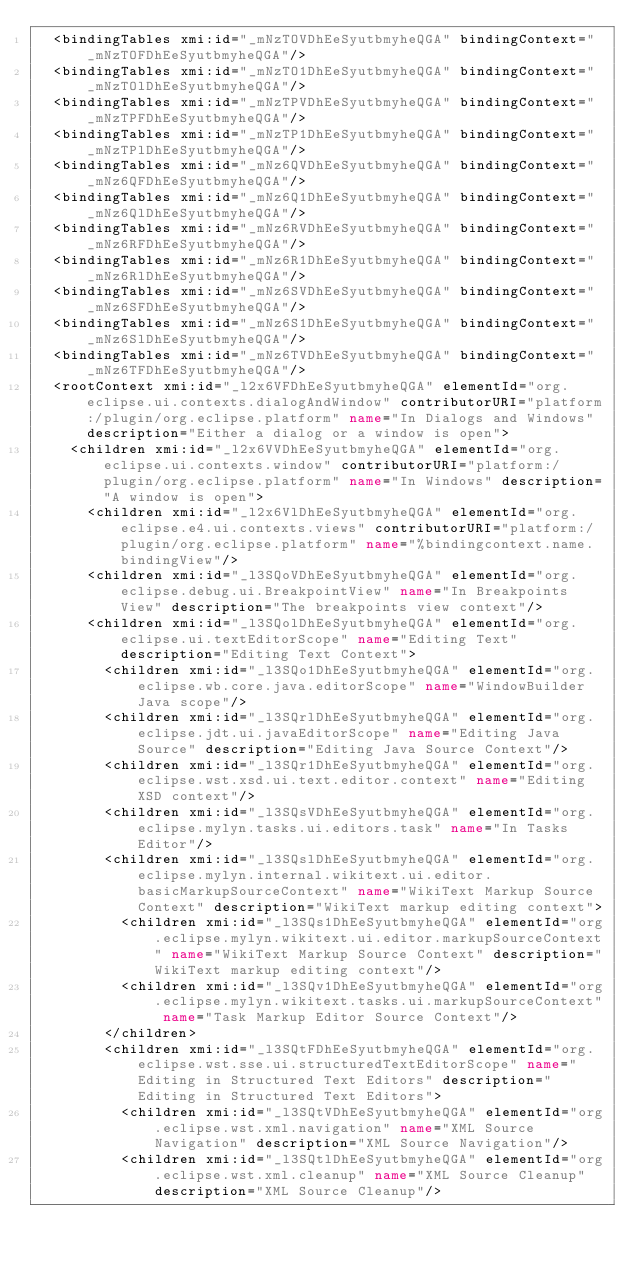Convert code to text. <code><loc_0><loc_0><loc_500><loc_500><_XML_>  <bindingTables xmi:id="_mNzTOVDhEeSyutbmyheQGA" bindingContext="_mNzTOFDhEeSyutbmyheQGA"/>
  <bindingTables xmi:id="_mNzTO1DhEeSyutbmyheQGA" bindingContext="_mNzTOlDhEeSyutbmyheQGA"/>
  <bindingTables xmi:id="_mNzTPVDhEeSyutbmyheQGA" bindingContext="_mNzTPFDhEeSyutbmyheQGA"/>
  <bindingTables xmi:id="_mNzTP1DhEeSyutbmyheQGA" bindingContext="_mNzTPlDhEeSyutbmyheQGA"/>
  <bindingTables xmi:id="_mNz6QVDhEeSyutbmyheQGA" bindingContext="_mNz6QFDhEeSyutbmyheQGA"/>
  <bindingTables xmi:id="_mNz6Q1DhEeSyutbmyheQGA" bindingContext="_mNz6QlDhEeSyutbmyheQGA"/>
  <bindingTables xmi:id="_mNz6RVDhEeSyutbmyheQGA" bindingContext="_mNz6RFDhEeSyutbmyheQGA"/>
  <bindingTables xmi:id="_mNz6R1DhEeSyutbmyheQGA" bindingContext="_mNz6RlDhEeSyutbmyheQGA"/>
  <bindingTables xmi:id="_mNz6SVDhEeSyutbmyheQGA" bindingContext="_mNz6SFDhEeSyutbmyheQGA"/>
  <bindingTables xmi:id="_mNz6S1DhEeSyutbmyheQGA" bindingContext="_mNz6SlDhEeSyutbmyheQGA"/>
  <bindingTables xmi:id="_mNz6TVDhEeSyutbmyheQGA" bindingContext="_mNz6TFDhEeSyutbmyheQGA"/>
  <rootContext xmi:id="_l2x6VFDhEeSyutbmyheQGA" elementId="org.eclipse.ui.contexts.dialogAndWindow" contributorURI="platform:/plugin/org.eclipse.platform" name="In Dialogs and Windows" description="Either a dialog or a window is open">
    <children xmi:id="_l2x6VVDhEeSyutbmyheQGA" elementId="org.eclipse.ui.contexts.window" contributorURI="platform:/plugin/org.eclipse.platform" name="In Windows" description="A window is open">
      <children xmi:id="_l2x6VlDhEeSyutbmyheQGA" elementId="org.eclipse.e4.ui.contexts.views" contributorURI="platform:/plugin/org.eclipse.platform" name="%bindingcontext.name.bindingView"/>
      <children xmi:id="_l3SQoVDhEeSyutbmyheQGA" elementId="org.eclipse.debug.ui.BreakpointView" name="In Breakpoints View" description="The breakpoints view context"/>
      <children xmi:id="_l3SQolDhEeSyutbmyheQGA" elementId="org.eclipse.ui.textEditorScope" name="Editing Text" description="Editing Text Context">
        <children xmi:id="_l3SQo1DhEeSyutbmyheQGA" elementId="org.eclipse.wb.core.java.editorScope" name="WindowBuilder Java scope"/>
        <children xmi:id="_l3SQrlDhEeSyutbmyheQGA" elementId="org.eclipse.jdt.ui.javaEditorScope" name="Editing Java Source" description="Editing Java Source Context"/>
        <children xmi:id="_l3SQr1DhEeSyutbmyheQGA" elementId="org.eclipse.wst.xsd.ui.text.editor.context" name="Editing XSD context"/>
        <children xmi:id="_l3SQsVDhEeSyutbmyheQGA" elementId="org.eclipse.mylyn.tasks.ui.editors.task" name="In Tasks Editor"/>
        <children xmi:id="_l3SQslDhEeSyutbmyheQGA" elementId="org.eclipse.mylyn.internal.wikitext.ui.editor.basicMarkupSourceContext" name="WikiText Markup Source Context" description="WikiText markup editing context">
          <children xmi:id="_l3SQs1DhEeSyutbmyheQGA" elementId="org.eclipse.mylyn.wikitext.ui.editor.markupSourceContext" name="WikiText Markup Source Context" description="WikiText markup editing context"/>
          <children xmi:id="_l3SQv1DhEeSyutbmyheQGA" elementId="org.eclipse.mylyn.wikitext.tasks.ui.markupSourceContext" name="Task Markup Editor Source Context"/>
        </children>
        <children xmi:id="_l3SQtFDhEeSyutbmyheQGA" elementId="org.eclipse.wst.sse.ui.structuredTextEditorScope" name="Editing in Structured Text Editors" description="Editing in Structured Text Editors">
          <children xmi:id="_l3SQtVDhEeSyutbmyheQGA" elementId="org.eclipse.wst.xml.navigation" name="XML Source Navigation" description="XML Source Navigation"/>
          <children xmi:id="_l3SQtlDhEeSyutbmyheQGA" elementId="org.eclipse.wst.xml.cleanup" name="XML Source Cleanup" description="XML Source Cleanup"/></code> 